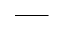Convert formula to latex. <formula><loc_0><loc_0><loc_500><loc_500>\_</formula> 